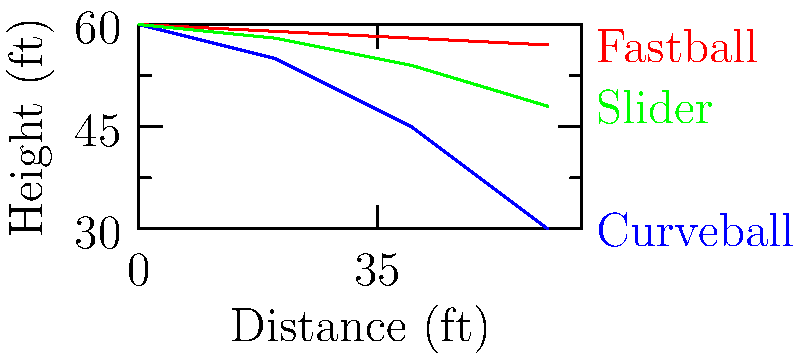Based on the trajectory patterns shown in the image, which machine learning algorithm would be most suitable for classifying different types of pitches in baseball? To determine the most suitable machine learning algorithm for classifying different types of pitches in baseball based on trajectory patterns, we need to consider the following steps:

1. Data characteristics:
   - The input data consists of sequences of ball positions (trajectory images).
   - Each pitch type has a distinct trajectory pattern.

2. Problem type:
   - This is a classification problem, as we need to categorize pitches into different types.

3. Data complexity:
   - The trajectories show non-linear patterns.
   - The differences between pitch types are based on the shape and curvature of the trajectories.

4. Feature extraction:
   - We need to extract relevant features from the trajectory data, such as velocity, acceleration, and curvature.

5. Temporal aspect:
   - The data represents a sequence of positions over time.

6. Algorithm considerations:
   - We need an algorithm that can handle sequential data and capture complex patterns.
   - The algorithm should be able to learn and recognize different trajectory shapes.

Considering these factors, the most suitable algorithm for this task would be a Recurrent Neural Network (RNN), specifically a Long Short-Term Memory (LSTM) network. Here's why:

- RNNs are designed to handle sequential data, making them ideal for processing trajectories.
- LSTMs, a type of RNN, can capture long-term dependencies in the data, which is crucial for understanding the entire pitch trajectory.
- LSTMs can learn complex, non-linear patterns in the data, allowing them to distinguish between different pitch types based on subtle differences in trajectories.
- They can automatically extract relevant features from the raw trajectory data, reducing the need for manual feature engineering.
- LSTMs have been successfully used in similar time-series classification tasks, including sports analytics.
Answer: Long Short-Term Memory (LSTM) network 